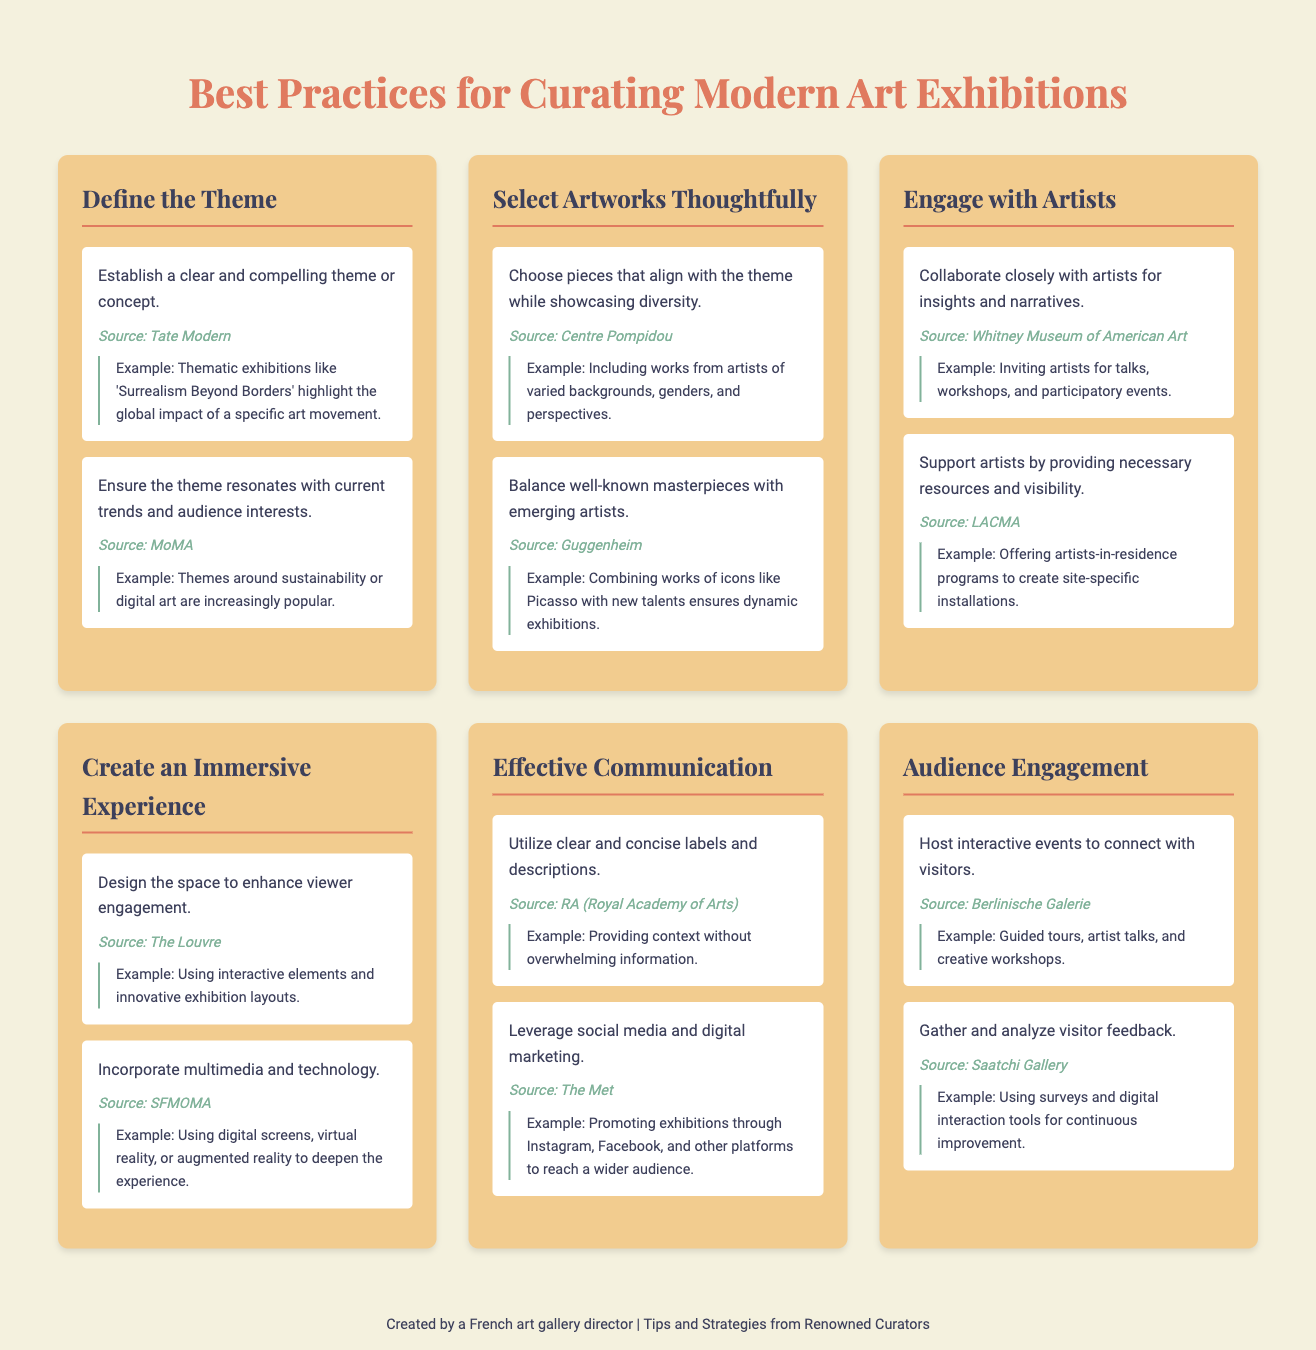What is one key element to establish in an exhibition? The document states that it is important to establish a clear and compelling theme or concept for an exhibition.
Answer: clear and compelling theme Which museum suggests to choose artworks thoughtfully? The Centre Pompidou is mentioned as a source for the tip about choosing pieces that align with the theme while showcasing diversity.
Answer: Centre Pompidou What organization emphasizes collaborating closely with artists? The Whitney Museum of American Art is referenced for the importance of collaborating closely with artists for insights and narratives.
Answer: Whitney Museum of American Art What strategy involves using digital screens to enhance viewer experience? Incorporating multimedia and technology, including digital screens, is highlighted as a way to create an immersive experience.
Answer: multimedia and technology What type of events should be hosted to connect with visitors? The document recommends hosting interactive events, such as guided tours and artist talks, to engage with visitors.
Answer: interactive events Which source stresses the importance of clear labels and descriptions? The Royal Academy of Arts is identified as the source that emphasizes the utility of clear and concise labels and descriptions.
Answer: RA (Royal Academy of Arts) What theme is becoming more popular according to the document? The document mentions that themes around sustainability or digital art are increasingly popular in exhibitions.
Answer: sustainability or digital art What must be gathered to improve exhibitions continuously? The document states that feedback from visitors should be gathered and analyzed for continuous improvement of exhibitions.
Answer: visitor feedback 